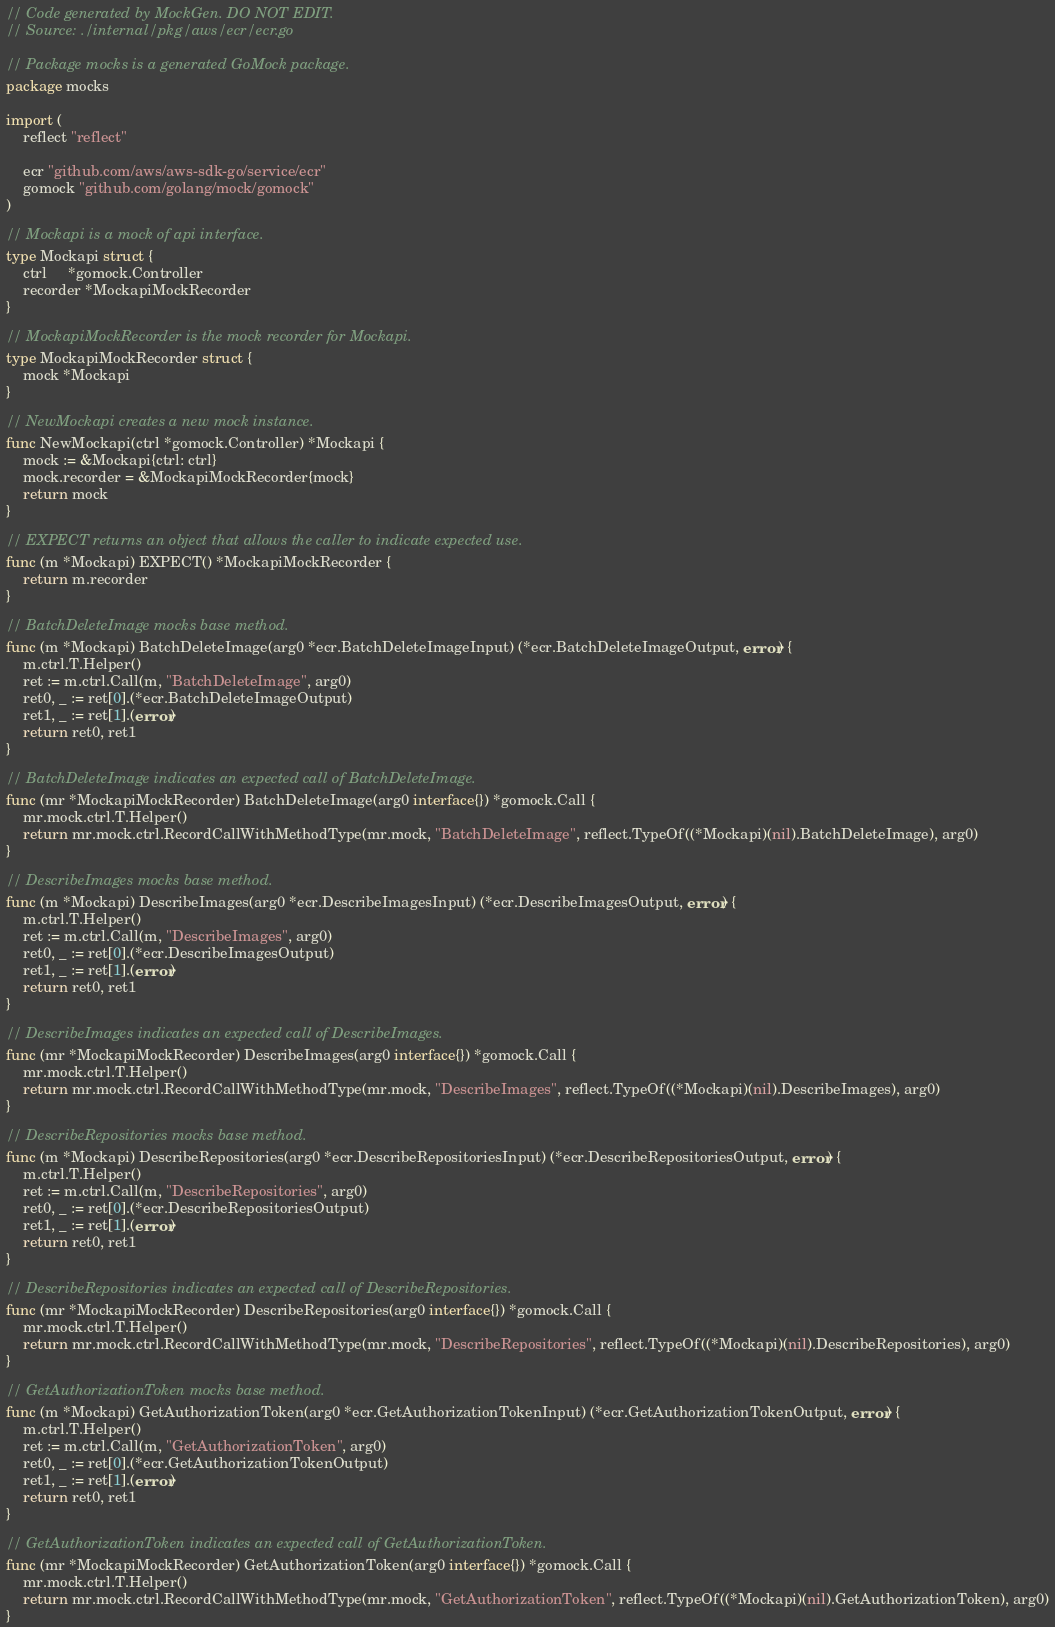Convert code to text. <code><loc_0><loc_0><loc_500><loc_500><_Go_>// Code generated by MockGen. DO NOT EDIT.
// Source: ./internal/pkg/aws/ecr/ecr.go

// Package mocks is a generated GoMock package.
package mocks

import (
	reflect "reflect"

	ecr "github.com/aws/aws-sdk-go/service/ecr"
	gomock "github.com/golang/mock/gomock"
)

// Mockapi is a mock of api interface.
type Mockapi struct {
	ctrl     *gomock.Controller
	recorder *MockapiMockRecorder
}

// MockapiMockRecorder is the mock recorder for Mockapi.
type MockapiMockRecorder struct {
	mock *Mockapi
}

// NewMockapi creates a new mock instance.
func NewMockapi(ctrl *gomock.Controller) *Mockapi {
	mock := &Mockapi{ctrl: ctrl}
	mock.recorder = &MockapiMockRecorder{mock}
	return mock
}

// EXPECT returns an object that allows the caller to indicate expected use.
func (m *Mockapi) EXPECT() *MockapiMockRecorder {
	return m.recorder
}

// BatchDeleteImage mocks base method.
func (m *Mockapi) BatchDeleteImage(arg0 *ecr.BatchDeleteImageInput) (*ecr.BatchDeleteImageOutput, error) {
	m.ctrl.T.Helper()
	ret := m.ctrl.Call(m, "BatchDeleteImage", arg0)
	ret0, _ := ret[0].(*ecr.BatchDeleteImageOutput)
	ret1, _ := ret[1].(error)
	return ret0, ret1
}

// BatchDeleteImage indicates an expected call of BatchDeleteImage.
func (mr *MockapiMockRecorder) BatchDeleteImage(arg0 interface{}) *gomock.Call {
	mr.mock.ctrl.T.Helper()
	return mr.mock.ctrl.RecordCallWithMethodType(mr.mock, "BatchDeleteImage", reflect.TypeOf((*Mockapi)(nil).BatchDeleteImage), arg0)
}

// DescribeImages mocks base method.
func (m *Mockapi) DescribeImages(arg0 *ecr.DescribeImagesInput) (*ecr.DescribeImagesOutput, error) {
	m.ctrl.T.Helper()
	ret := m.ctrl.Call(m, "DescribeImages", arg0)
	ret0, _ := ret[0].(*ecr.DescribeImagesOutput)
	ret1, _ := ret[1].(error)
	return ret0, ret1
}

// DescribeImages indicates an expected call of DescribeImages.
func (mr *MockapiMockRecorder) DescribeImages(arg0 interface{}) *gomock.Call {
	mr.mock.ctrl.T.Helper()
	return mr.mock.ctrl.RecordCallWithMethodType(mr.mock, "DescribeImages", reflect.TypeOf((*Mockapi)(nil).DescribeImages), arg0)
}

// DescribeRepositories mocks base method.
func (m *Mockapi) DescribeRepositories(arg0 *ecr.DescribeRepositoriesInput) (*ecr.DescribeRepositoriesOutput, error) {
	m.ctrl.T.Helper()
	ret := m.ctrl.Call(m, "DescribeRepositories", arg0)
	ret0, _ := ret[0].(*ecr.DescribeRepositoriesOutput)
	ret1, _ := ret[1].(error)
	return ret0, ret1
}

// DescribeRepositories indicates an expected call of DescribeRepositories.
func (mr *MockapiMockRecorder) DescribeRepositories(arg0 interface{}) *gomock.Call {
	mr.mock.ctrl.T.Helper()
	return mr.mock.ctrl.RecordCallWithMethodType(mr.mock, "DescribeRepositories", reflect.TypeOf((*Mockapi)(nil).DescribeRepositories), arg0)
}

// GetAuthorizationToken mocks base method.
func (m *Mockapi) GetAuthorizationToken(arg0 *ecr.GetAuthorizationTokenInput) (*ecr.GetAuthorizationTokenOutput, error) {
	m.ctrl.T.Helper()
	ret := m.ctrl.Call(m, "GetAuthorizationToken", arg0)
	ret0, _ := ret[0].(*ecr.GetAuthorizationTokenOutput)
	ret1, _ := ret[1].(error)
	return ret0, ret1
}

// GetAuthorizationToken indicates an expected call of GetAuthorizationToken.
func (mr *MockapiMockRecorder) GetAuthorizationToken(arg0 interface{}) *gomock.Call {
	mr.mock.ctrl.T.Helper()
	return mr.mock.ctrl.RecordCallWithMethodType(mr.mock, "GetAuthorizationToken", reflect.TypeOf((*Mockapi)(nil).GetAuthorizationToken), arg0)
}
</code> 